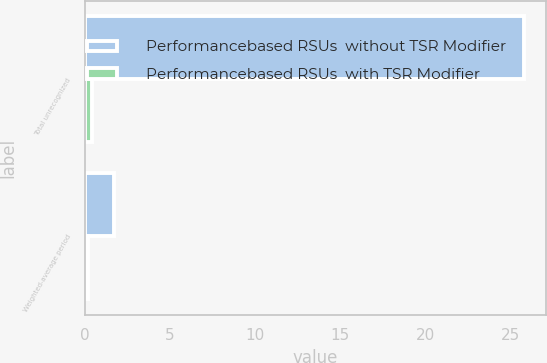<chart> <loc_0><loc_0><loc_500><loc_500><stacked_bar_chart><ecel><fcel>Total unrecognized<fcel>Weighted-average period<nl><fcel>Performancebased RSUs  without TSR Modifier<fcel>25.8<fcel>1.7<nl><fcel>Performancebased RSUs  with TSR Modifier<fcel>0.4<fcel>0.2<nl></chart> 